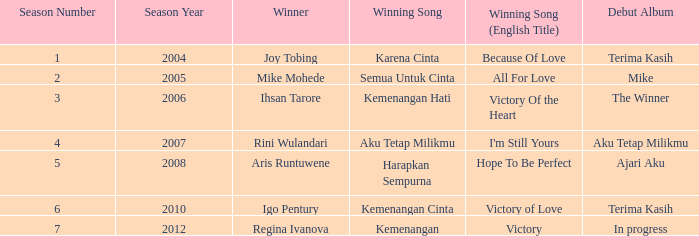Who won with the song kemenangan cinta? Igo Pentury. 